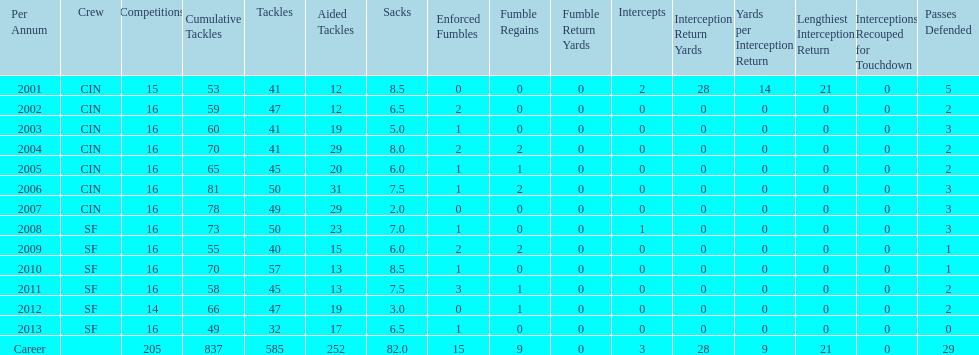How many years did he play where he did not recover a fumble? 7. 